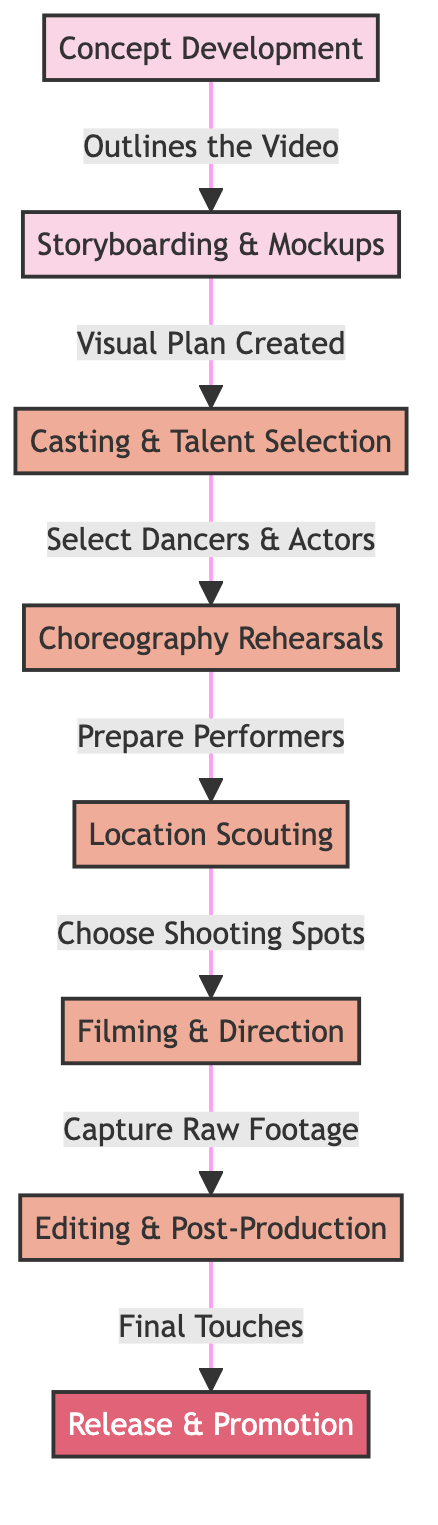What is the first stage in the music video production process? The diagram starts with the "Concept Development" stage, which outlines the video idea before any other steps are taken.
Answer: Concept Development How many main stages are in the music video production process? There are a total of eight stages depicted in the diagram, which include Concept Development, Storyboarding & Mockups, Casting & Talent Selection, Choreography Rehearsals, Location Scouting, Filming & Direction, Editing & Post-Production, and Release & Promotion.
Answer: Eight What follows after storyboarding and mockups? After "Storyboarding & Mockups," the next stage in the process is "Casting & Talent Selection." This indicates the flow of tasks in the production.
Answer: Casting & Talent Selection Which step comes before filming? Prior to "Filming & Direction," the diagram indicates "Location Scouting," which is necessary to select appropriate shooting spots for the video.
Answer: Location Scouting What is the final stage of the music video production process? The last stage, as indicated in the diagram, is "Release & Promotion," which concludes the production process by making the video available to the public.
Answer: Release & Promotion What input flows into the rehearsal stage? The "Casting & Talent Selection" stage feeds directly into the "Choreography Rehearsals" stage. This shows that only after selecting the talent can rehearsals be organized.
Answer: Casting & Talent Selection Identify the relationship between editing and release. The diagram shows that "Editing & Post-Production" leads into "Release & Promotion," suggesting that the final touches made during editing directly impact the promotional aspect before the video's public debut.
Answer: Editing & Post-Production Which stage involves capturing raw footage? The stage labeled "Filming & Direction" is specifically where the raw footage is captured, indicating it is a key component of the production process.
Answer: Filming & Direction 